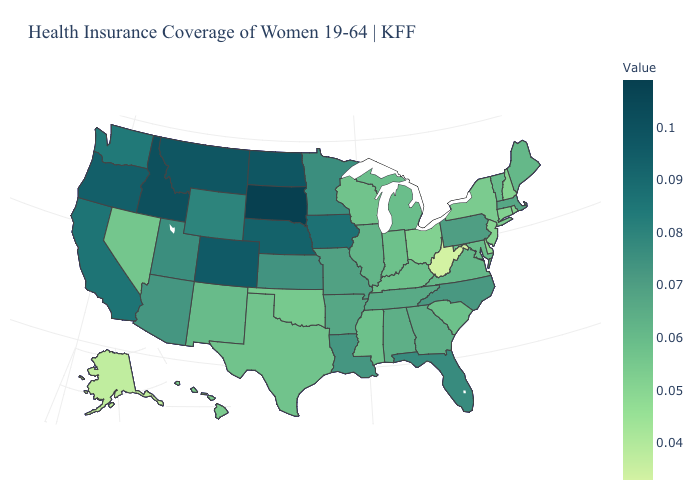Among the states that border Rhode Island , which have the lowest value?
Keep it brief. Connecticut. Among the states that border Montana , which have the lowest value?
Write a very short answer. Wyoming. Is the legend a continuous bar?
Give a very brief answer. Yes. Does South Dakota have the highest value in the USA?
Give a very brief answer. Yes. Which states have the lowest value in the USA?
Concise answer only. West Virginia. 